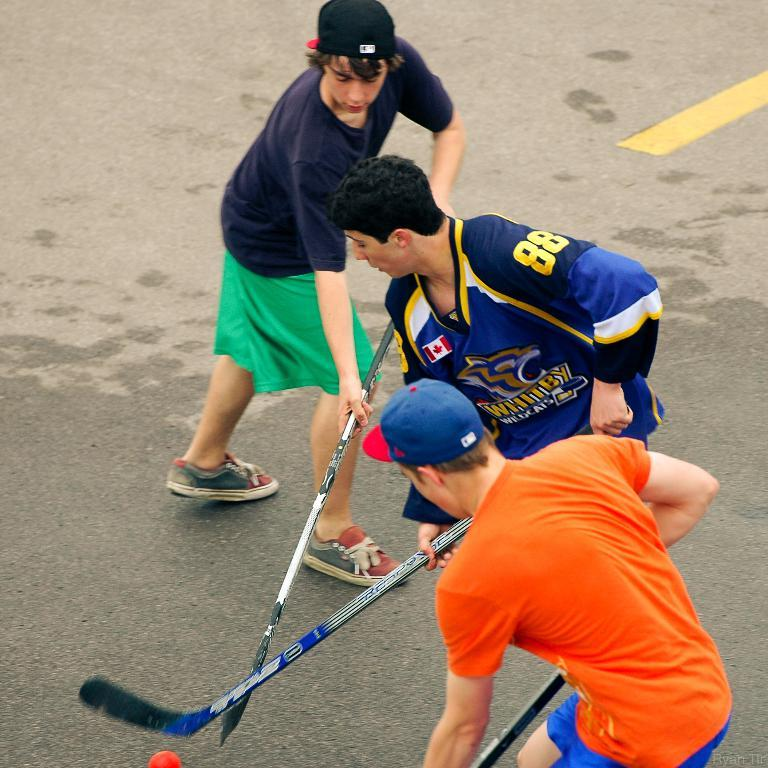How many people are in the image? There are three men in the image. What are two of the men wearing on their heads? Two of the men are wearing caps. What are the men holding in their hands? All three men are holding sticks. What object is present in the image that is not a person or a stick? There is an orange ball in the image. Can you tell me how many babies are visible in the image? There are no babies present in the image. What type of sweater is the man in the middle wearing? The men in the image are not wearing sweaters; they are wearing caps and holding sticks. 